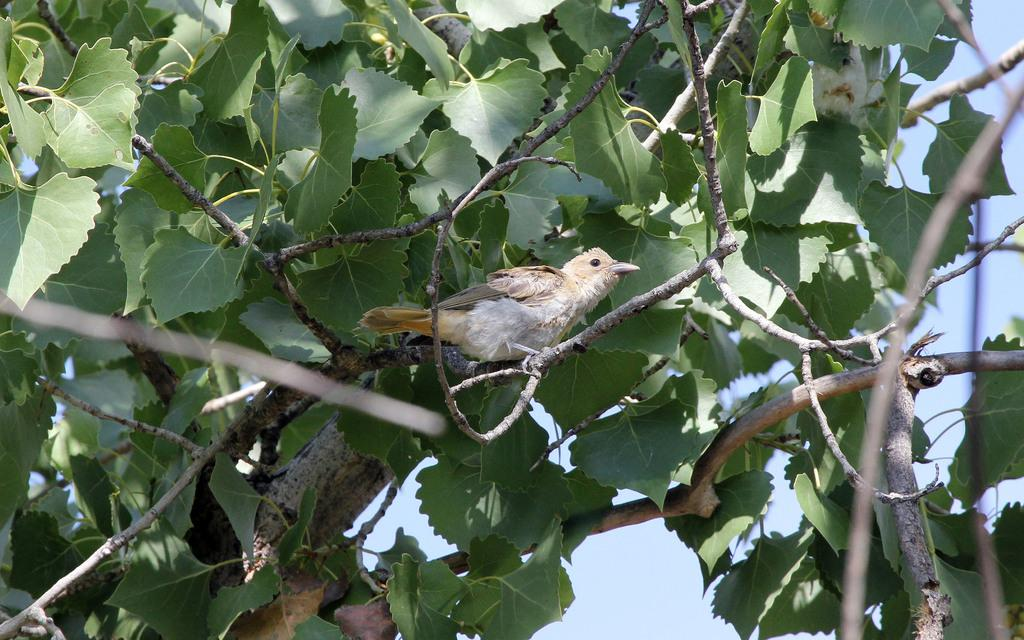What type of natural elements are present in the image? There are leaves and branches of a tree in the image. What type of animal can be seen in the image? There is a bird in the image. What can be seen in the background of the image? The sky is visible in the background of the image. What is the price of the tomatoes in the image? There are no tomatoes present in the image, so it is not possible to determine their price. 